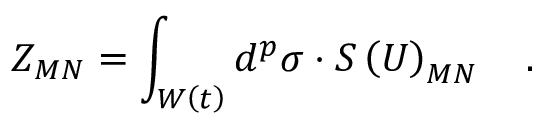Convert formula to latex. <formula><loc_0><loc_0><loc_500><loc_500>Z _ { M N } = \int _ { W \left ( t \right ) } d ^ { p } \sigma \cdot S \left ( U \right ) _ { M N } \quad .</formula> 